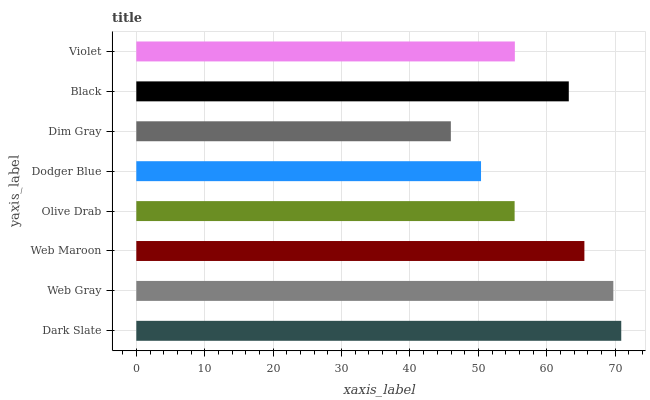Is Dim Gray the minimum?
Answer yes or no. Yes. Is Dark Slate the maximum?
Answer yes or no. Yes. Is Web Gray the minimum?
Answer yes or no. No. Is Web Gray the maximum?
Answer yes or no. No. Is Dark Slate greater than Web Gray?
Answer yes or no. Yes. Is Web Gray less than Dark Slate?
Answer yes or no. Yes. Is Web Gray greater than Dark Slate?
Answer yes or no. No. Is Dark Slate less than Web Gray?
Answer yes or no. No. Is Black the high median?
Answer yes or no. Yes. Is Violet the low median?
Answer yes or no. Yes. Is Violet the high median?
Answer yes or no. No. Is Dim Gray the low median?
Answer yes or no. No. 